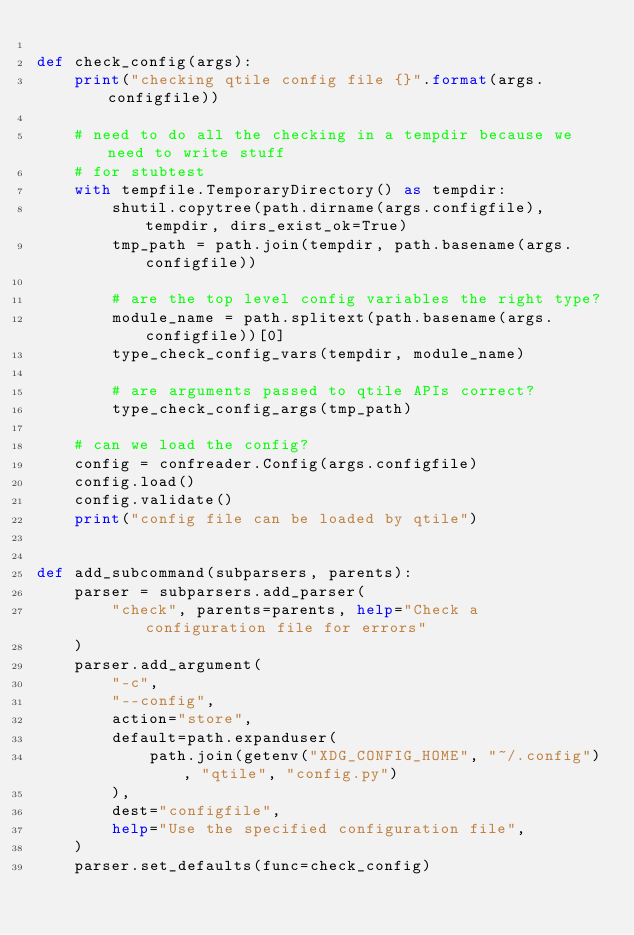<code> <loc_0><loc_0><loc_500><loc_500><_Python_>
def check_config(args):
    print("checking qtile config file {}".format(args.configfile))

    # need to do all the checking in a tempdir because we need to write stuff
    # for stubtest
    with tempfile.TemporaryDirectory() as tempdir:
        shutil.copytree(path.dirname(args.configfile), tempdir, dirs_exist_ok=True)
        tmp_path = path.join(tempdir, path.basename(args.configfile))

        # are the top level config variables the right type?
        module_name = path.splitext(path.basename(args.configfile))[0]
        type_check_config_vars(tempdir, module_name)

        # are arguments passed to qtile APIs correct?
        type_check_config_args(tmp_path)

    # can we load the config?
    config = confreader.Config(args.configfile)
    config.load()
    config.validate()
    print("config file can be loaded by qtile")


def add_subcommand(subparsers, parents):
    parser = subparsers.add_parser(
        "check", parents=parents, help="Check a configuration file for errors"
    )
    parser.add_argument(
        "-c",
        "--config",
        action="store",
        default=path.expanduser(
            path.join(getenv("XDG_CONFIG_HOME", "~/.config"), "qtile", "config.py")
        ),
        dest="configfile",
        help="Use the specified configuration file",
    )
    parser.set_defaults(func=check_config)
</code> 